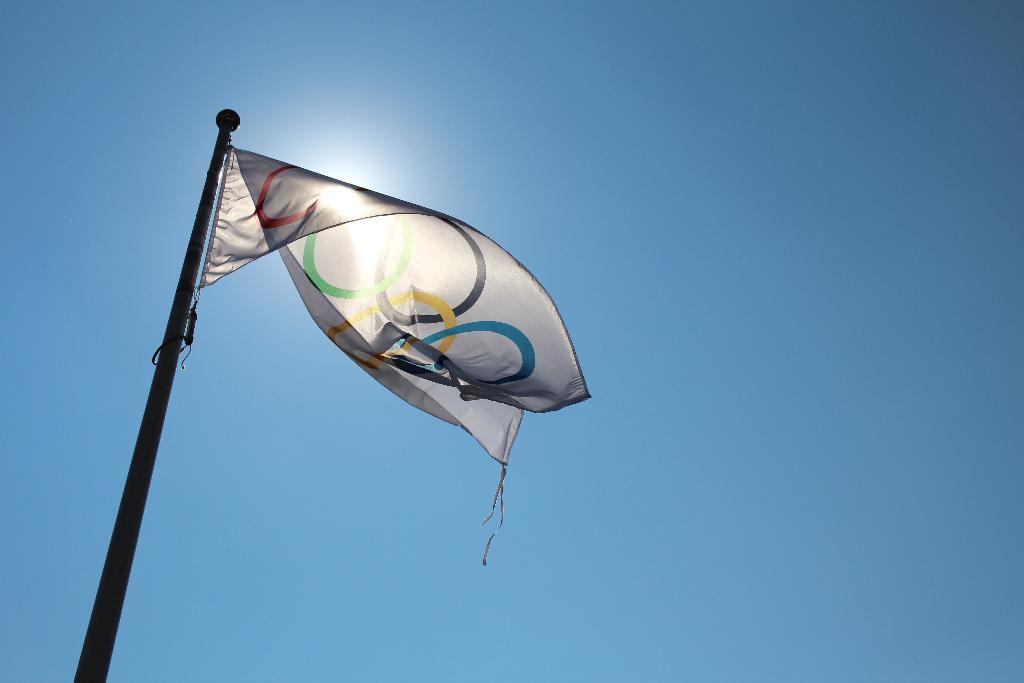Can you describe this image briefly? In this picture I can see a flag with a pole, and in the background there is the sky. 